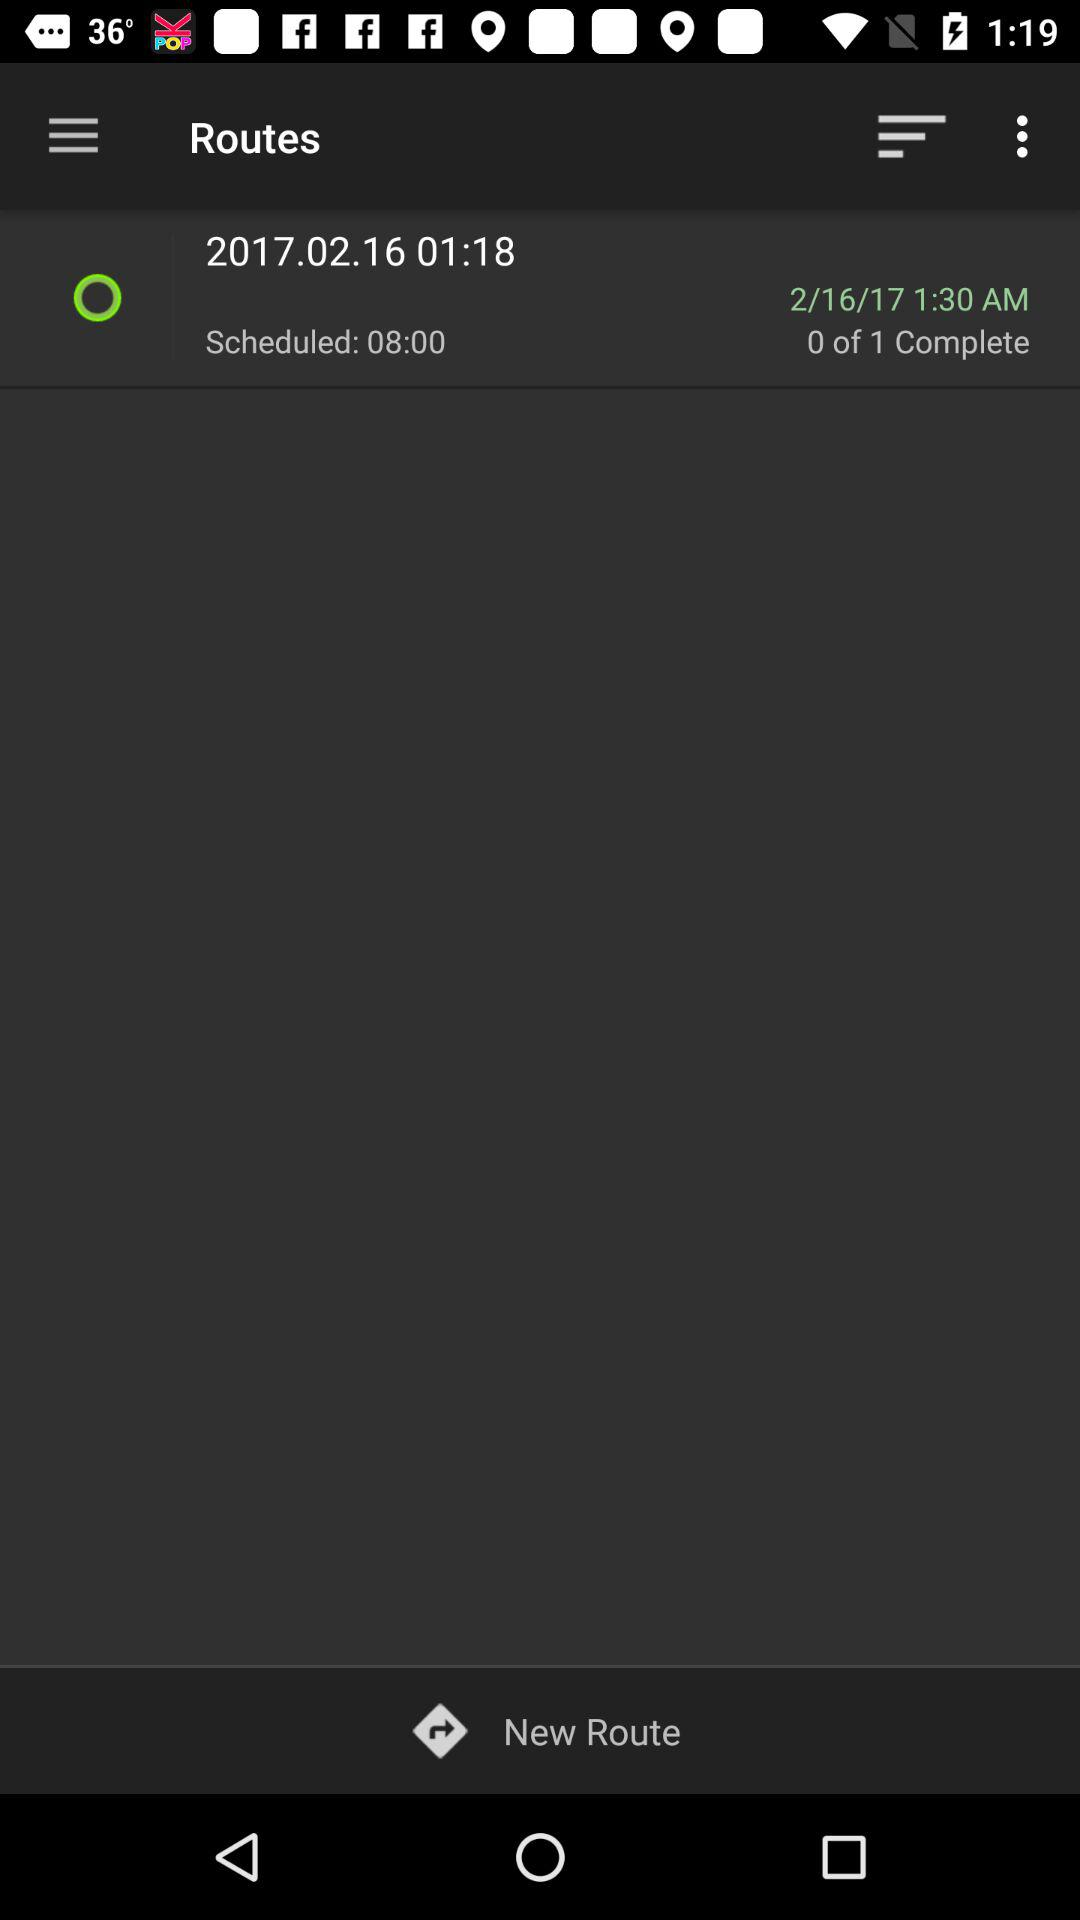How many routes are completed? There are 0 routes completed. 